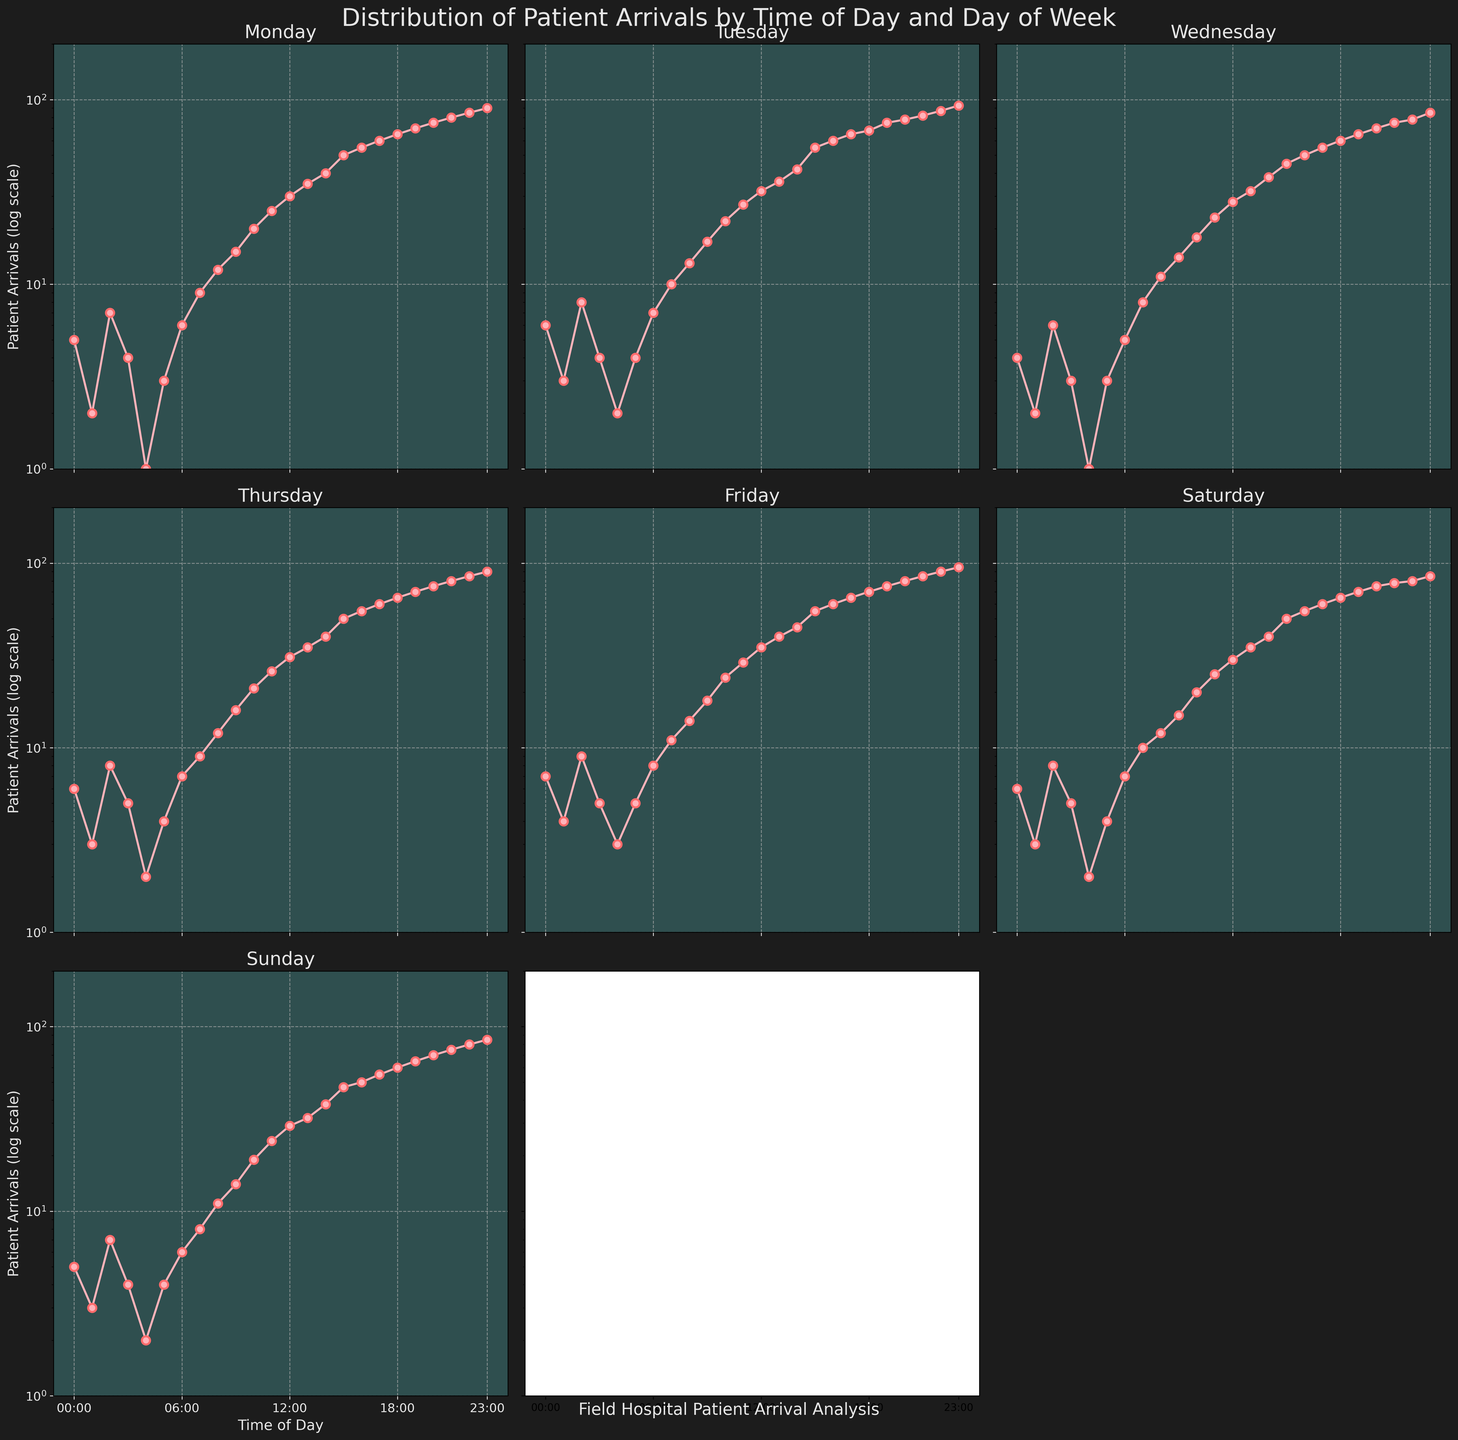What's the title of the plot? The title is located at the top of the figure in large, bold text. The title reads, "Distribution of Patient Arrivals by Time of Day and Day of Week".
Answer: Distribution of Patient Arrivals by Time of Day and Day of Week What does the y-axis represent? The y-axis is labeled "Patient Arrivals (log scale)", indicating that it shows the number of patient arrivals on a log scale.
Answer: Patient Arrivals (log scale) Which day has the highest patient arrivals recorded at 23:00? By looking at the patient arrival points at 23:00 for each day, Friday has the highest number, which is approximately 95.
Answer: Friday Is there any day where the patient arrivals remain below 10 throughout the day? Since all days have a log scale, it's easy to spot the data points that start below 10 and stay below 10 throughout the day. There is no such day as all days exceed this number at some point in time.
Answer: No Which day has the lowest patient arrivals at 00:00? Checking the data points at 00:00 for each day, Monday has the lowest patient arrivals, which is 5.
Answer: Monday On which day do patient arrivals begin to exponentially increase from mid-day to evening? Observing the log scale and the steep rise in the plot from around 12:00 onwards, this trend appears in all days significantly but is most sharp in Friday starting around 15:00.
Answer: Friday How do patient arrivals at 06:00 on Wednesday compare to those on Friday? On Wednesday, the number of patient arrivals at 06:00 is around 5, while on Friday, it is 8. Hence, Friday has more patient arrivals at 06:00.
Answer: Friday What can you infer about Sunday in terms of afternoon patient traffic compared to Monday? Examining the afternoon slots (from 12:00 to 18:00), Sunday shows fewer patient arrivals compared to Monday; for instance, at 15:00 (Monday: 50, Sunday: 47) and at 18:00 (Monday: 65, Sunday: 60).
Answer: Monday Which two days have the most similar patient arrival patterns? Considering the relative slopes and overlaps in the log scale plots, the patterns of patient arrivals on Monday and Thursday are the most similar visually.
Answer: Monday and Thursday 